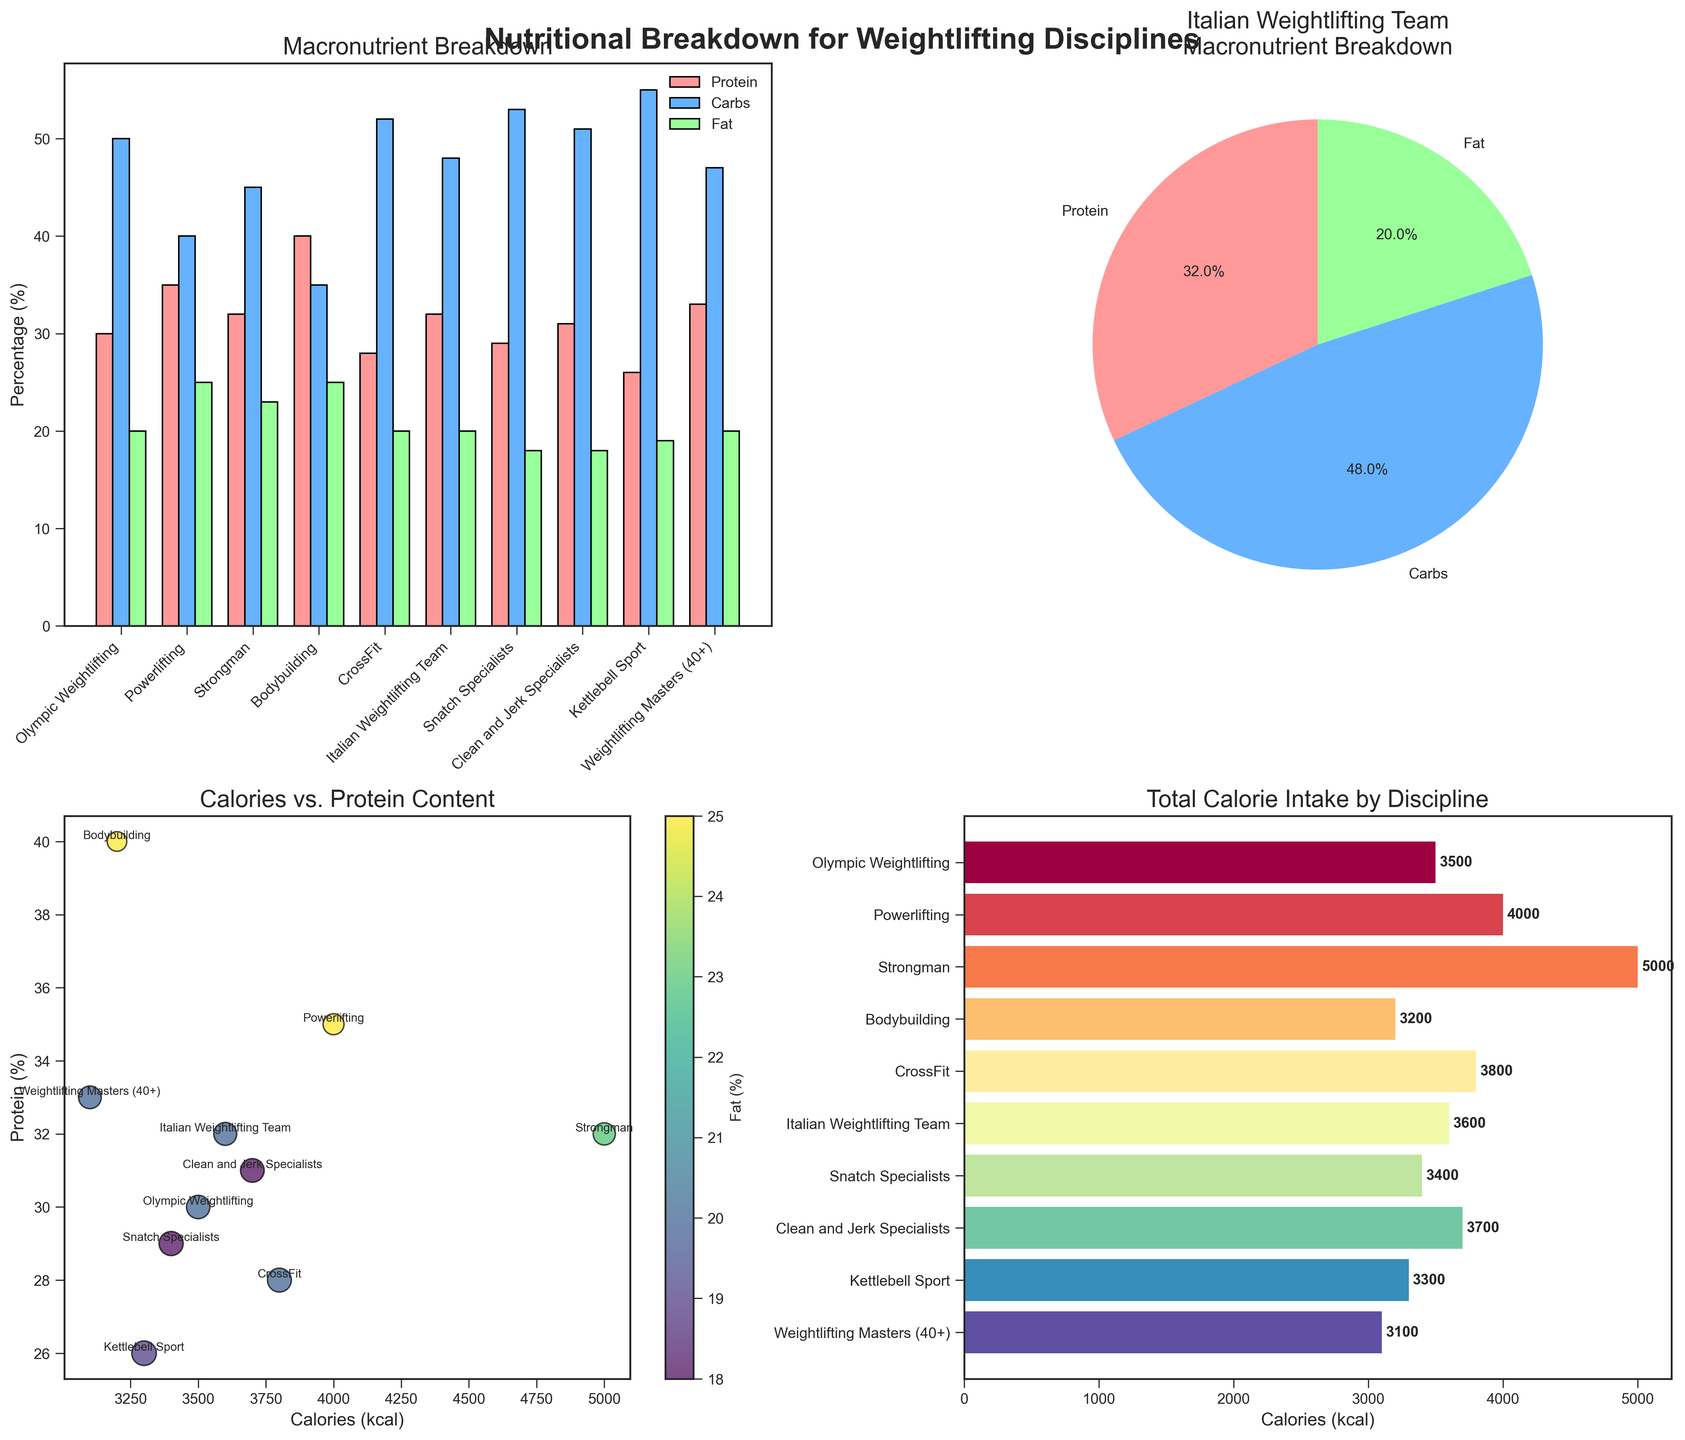What is the percentage of protein intake for the Bodybuilding discipline? In the bar plot titled 'Macronutrient Breakdown', locate the bar for the Bodybuilding discipline. The percentage values are shown for Protein, Carbs, and Fat.
Answer: 40% Which discipline has the highest calorie intake, and what is the value? Look at the horizontal bar chart titled 'Total Calorie Intake by Discipline'. The highest bar represents the discipline with the highest calorie intake, and the value is labeled at the end of the bar.
Answer: Strongman, 5000 kcal What is the relationship between protein percentage and calorie intake for Olympic Weightlifting? Refer to the scatter plot titled 'Calories vs. Protein Content'. For Olympic Weightlifting, find the point labeled on the plot and check its x-axis (calories) and y-axis (protein) values.
Answer: Protein: 30%, Calories: 3500 kcal Which discipline has the highest carbs percentage? In the bar plot titled 'Macronutrient Breakdown', the tallest bar in the Carbs (%) group (usually the middle bars in each set) indicates the highest carbs percentage.
Answer: Kettlebell Sport, 55% How is the macronutrient breakdown of the Italian Weightlifting Team depicted? Refer to the pie chart titled 'Italian Weightlifting Team Macronutrient Breakdown'. The chart shows the breakdown with percentages of Protein, Carbs, and Fat.
Answer: 32% Protein, 48% Carbs, 20% Fat What is the difference in the protein percentage between Powerlifting and Snatch Specialists? Identify the protein percentages from the bar plot titled 'Macronutrient Breakdown'. Subtract the percentage of Snatch Specialists from Powerlifting.
Answer: 35% - 29% = 6% Is there a correlation between carbohydrate percentage and calorie intake? Look at the scatter plot titled 'Calories vs. Protein Content'. Although protein is on the y-axis, the size of the scatter points indicates the carbohydrate percentage. Check if larger points correlate with certain calorie values.
Answer: No clear visible correlation What discipline has the lowest fat percentage, and what is the value? Find the discipline with the shortest bar in the Fat (%) category on the bar plot titled 'Macronutrient Breakdown'.
Answer: Snatch Specialists and Clean and Jerk Specialists, 18% How does CrossFit's macronutrient breakdown compare to Powerlifting in terms of carbs percentage? Compare the carb percentages from the bar plot titled 'Macronutrient Breakdown' for CrossFit and Powerlifting.
Answer: CrossFit: 52%, Powerlifting: 40%, CrossFit has higher carbs percentage What does the central color gradient in the scatter plot represent? Refer to the color bar next to the scatter plot titled 'Calories vs. Protein Content'. The gradient indicates the Fat percentage.
Answer: Fat (%) 